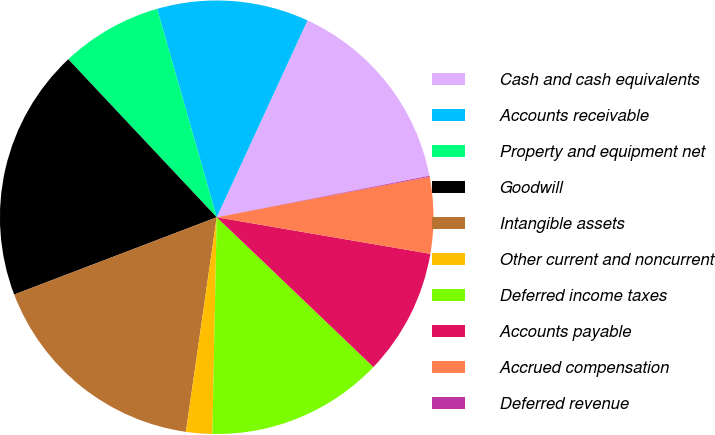<chart> <loc_0><loc_0><loc_500><loc_500><pie_chart><fcel>Cash and cash equivalents<fcel>Accounts receivable<fcel>Property and equipment net<fcel>Goodwill<fcel>Intangible assets<fcel>Other current and noncurrent<fcel>Deferred income taxes<fcel>Accounts payable<fcel>Accrued compensation<fcel>Deferred revenue<nl><fcel>15.06%<fcel>11.31%<fcel>7.57%<fcel>18.8%<fcel>16.93%<fcel>1.95%<fcel>13.18%<fcel>9.44%<fcel>5.69%<fcel>0.07%<nl></chart> 